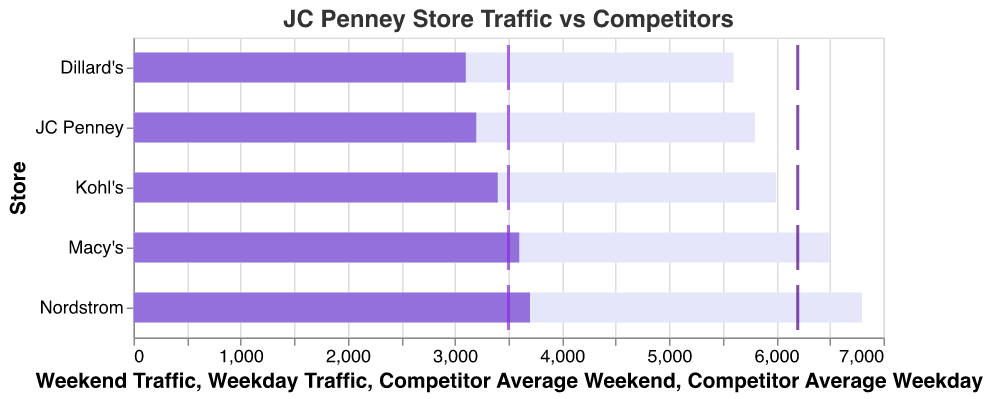What's the title of the plot? The title is displayed at the top of the figure and reads "JC Penney Store Traffic vs Competitors."
Answer: "JC Penney Store Traffic vs Competitors" What are the two traffic categories compared in the figure? The figure compares Weekday Traffic and Weekend Traffic.
Answer: Weekday Traffic and Weekend Traffic What is the sum of Weekday and Weekend Traffic for JC Penney? JC Penney's Weekday Traffic is 3200 and Weekend Traffic is 5800. Summing these gives 3200 + 5800 = 9000.
Answer: 9000 What is the average Weekend Traffic across all the stores? Sum up the Weekend Traffic for all stores: 5800 (JC Penney) + 6500 (Macy's) + 6000 (Kohl's) + 5600 (Dillard's) + 6800 (Nordstrom) = 30700. Divide by the number of stores, which is 5: 30700 / 5 = 6140.
Answer: 6140 What is the difference in Weekend Traffic between Nordstrom and Dillard's? Nordstrom's Weekend Traffic is 6800, and Dillard's is 5600. The difference is 6800 - 5600 = 1200.
Answer: 1200 Which store has the highest Weekend Traffic? Nordstrom has the highest Weekend Traffic at 6800.
Answer: Nordstrom Is JC Penney’s Weekday Traffic higher or lower than Macy’s? JC Penney's Weekday Traffic is 3200, whereas Macy's is 3600. JC Penney's Weekday Traffic is lower than Macy's.
Answer: Lower Which store has the lowest Weekday Traffic? Dillard's has the lowest Weekday Traffic at 3100.
Answer: Dillard's What do the tick marks on the plot represent? The tick marks represent the Competitor Average Weekday and Weekend Traffic values.
Answer: Competitor Average How does JC Penney's Weekend Traffic compare to the competitor average? JC Penney's Weekend Traffic is 5800, which is lower than the competitor average of 6200.
Answer: Lower Is there any store which exceeds the competitor average in both Weekday and Weekend Traffic? Based on the tick marks and bar lengths, Nordstrom exceeds the competitor average in both Weekday (3700 > 3500) and Weekend Traffic (6800 > 6200).
Answer: Yes, Nordstrom 